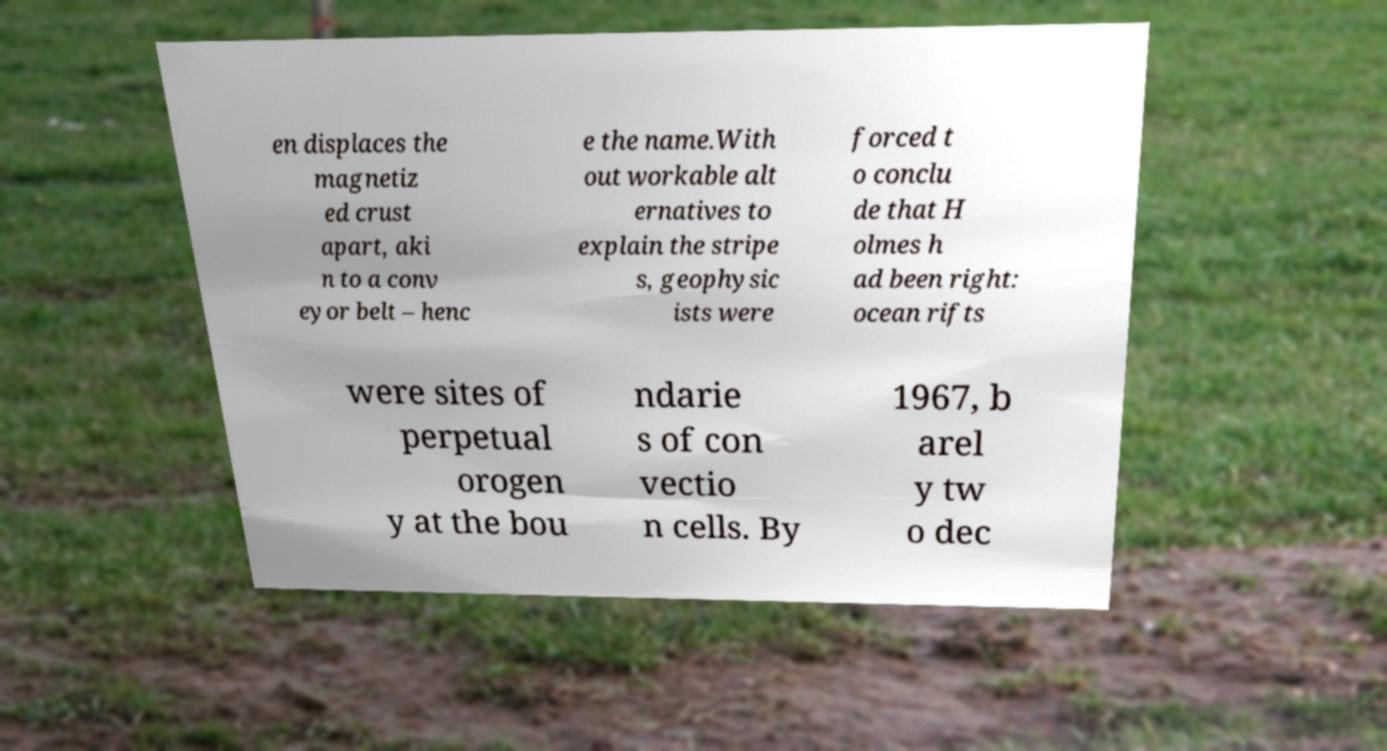Could you extract and type out the text from this image? en displaces the magnetiz ed crust apart, aki n to a conv eyor belt – henc e the name.With out workable alt ernatives to explain the stripe s, geophysic ists were forced t o conclu de that H olmes h ad been right: ocean rifts were sites of perpetual orogen y at the bou ndarie s of con vectio n cells. By 1967, b arel y tw o dec 